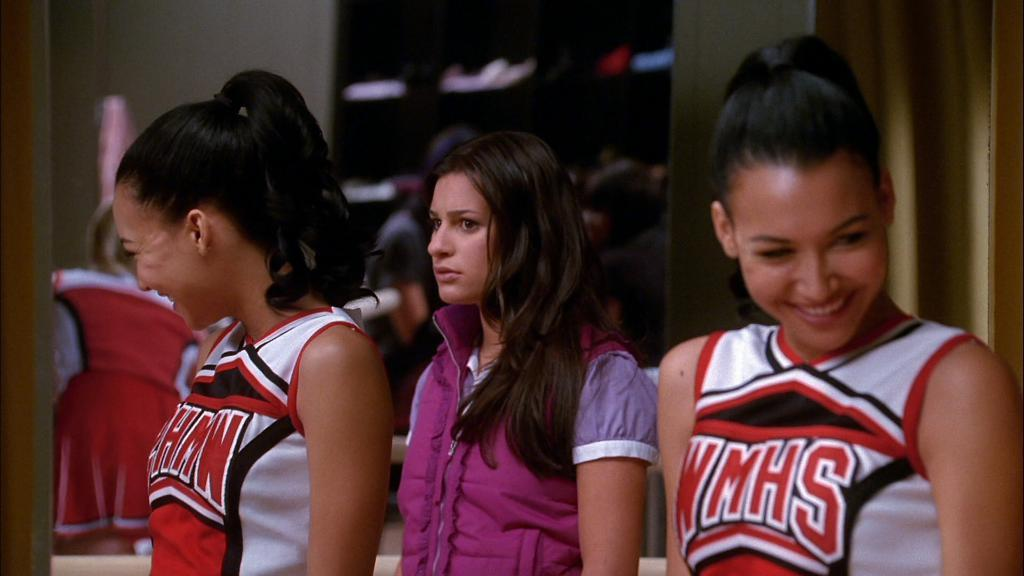<image>
Summarize the visual content of the image. Two girls wearing cheerleader uniforms that say WMHS. 